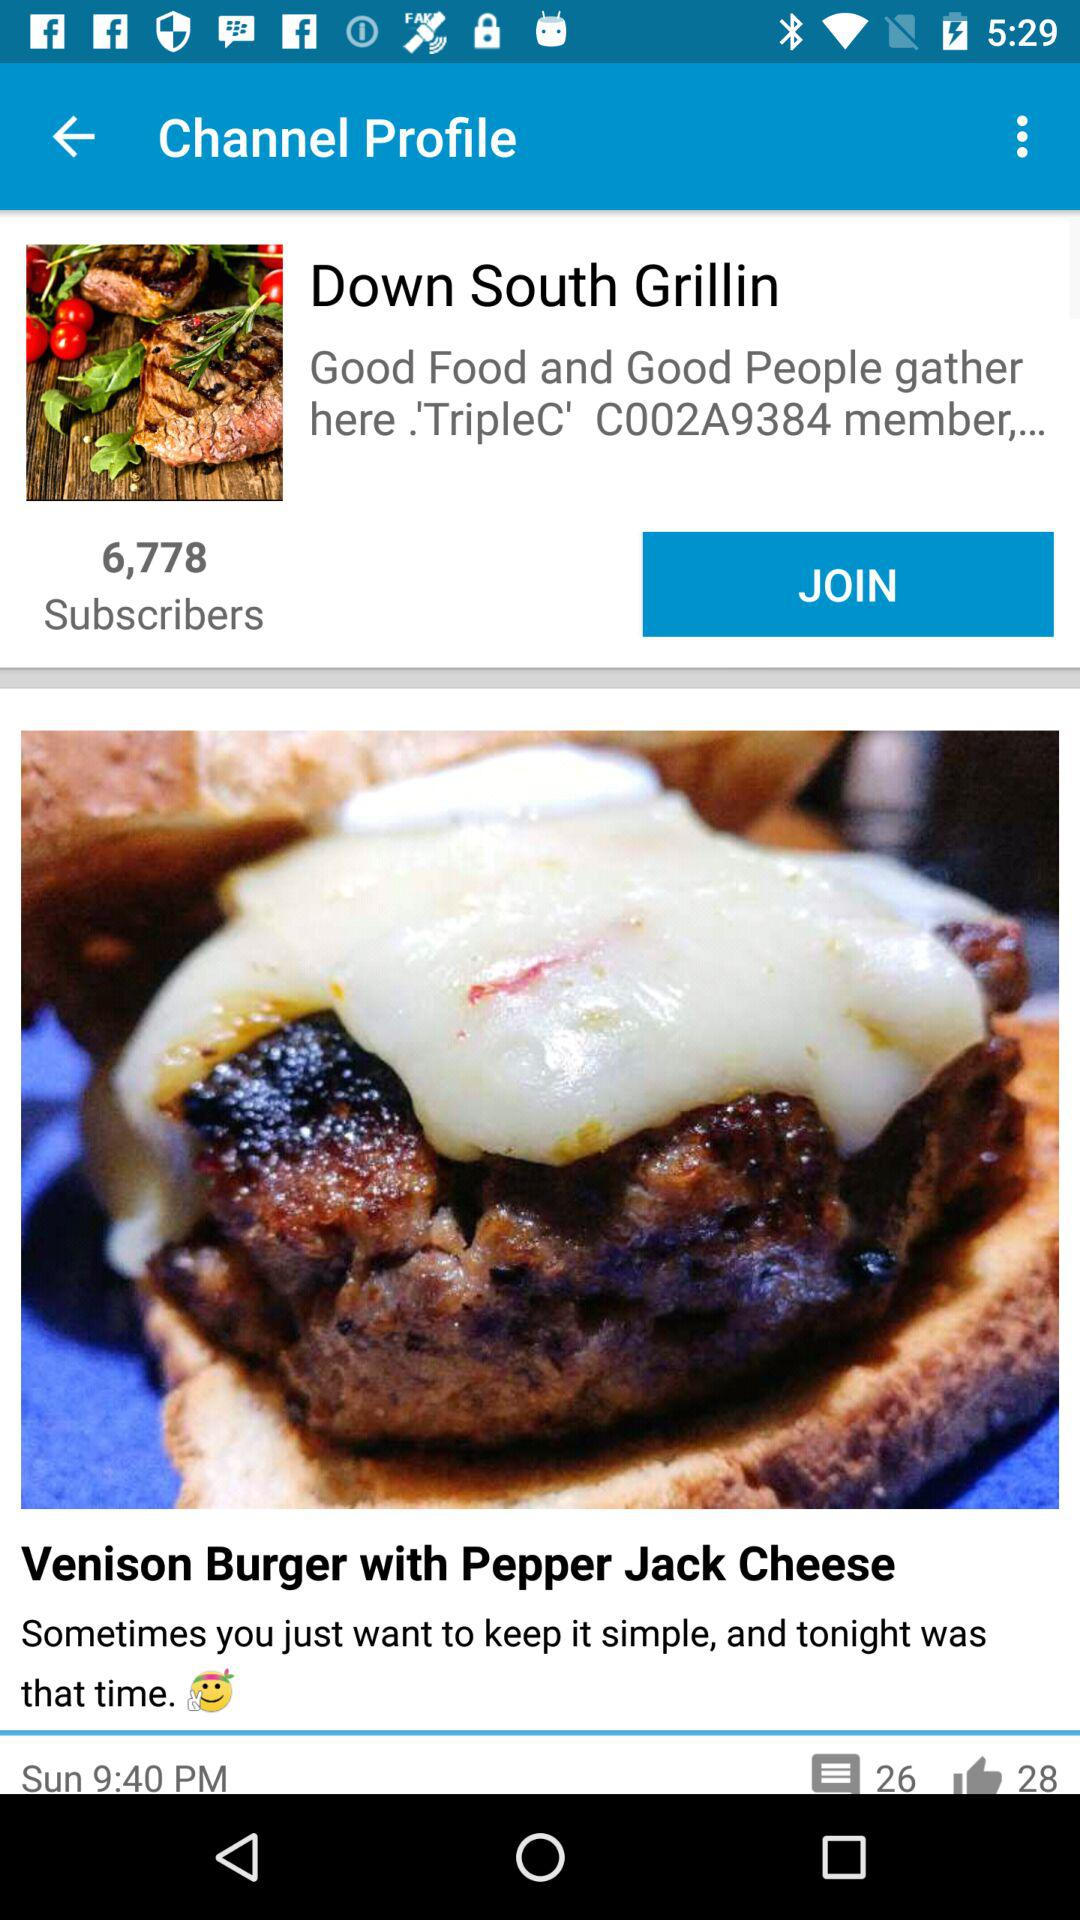How many subscribers does the Down South Grillin channel have? The Down South Grillin channel have 6,778 subscribers. 